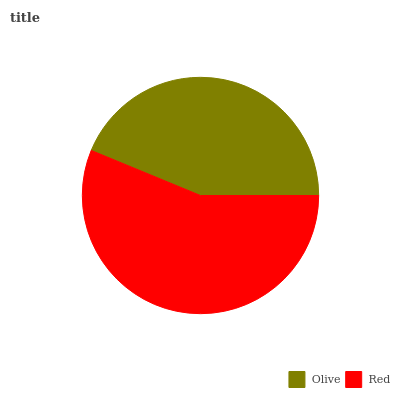Is Olive the minimum?
Answer yes or no. Yes. Is Red the maximum?
Answer yes or no. Yes. Is Red the minimum?
Answer yes or no. No. Is Red greater than Olive?
Answer yes or no. Yes. Is Olive less than Red?
Answer yes or no. Yes. Is Olive greater than Red?
Answer yes or no. No. Is Red less than Olive?
Answer yes or no. No. Is Red the high median?
Answer yes or no. Yes. Is Olive the low median?
Answer yes or no. Yes. Is Olive the high median?
Answer yes or no. No. Is Red the low median?
Answer yes or no. No. 